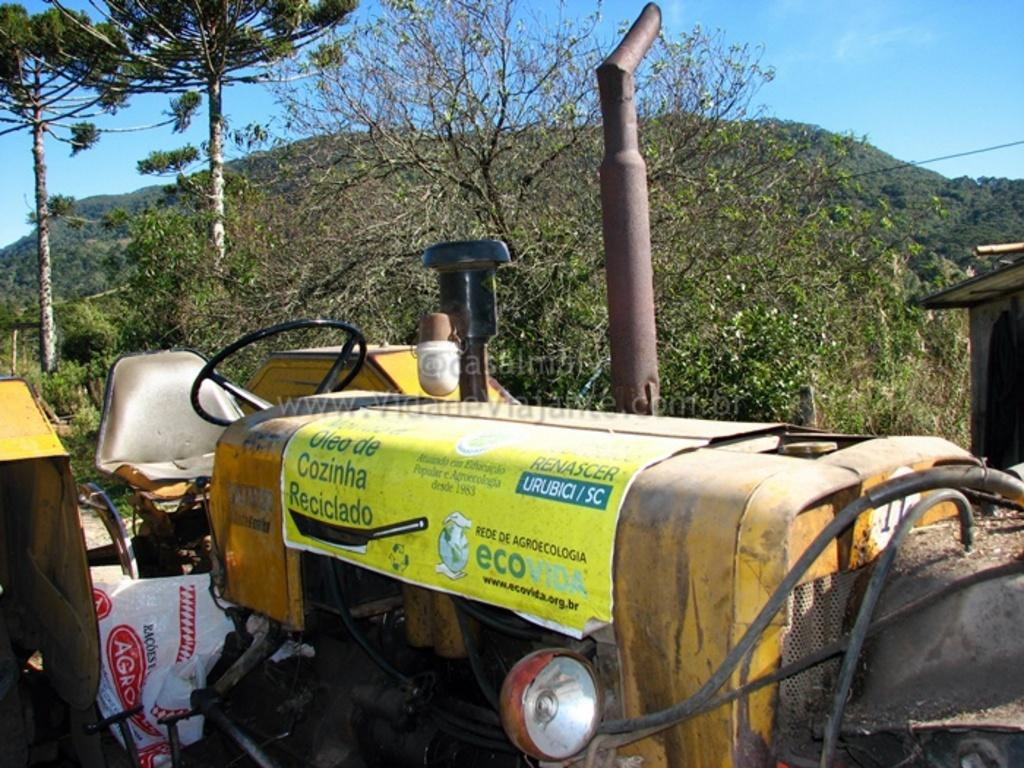What is the main subject at the bottom of the image? There is a tractor at the bottom of the image. What can be seen in the background of the image? Trees and a mountain are visible in the background of the image. What is visible at the top of the image? The sky is visible at the top of the image. How many feet are visible on the tractor in the image? There are no visible feet on the tractor in the image, as it is a machine and not a living being. 